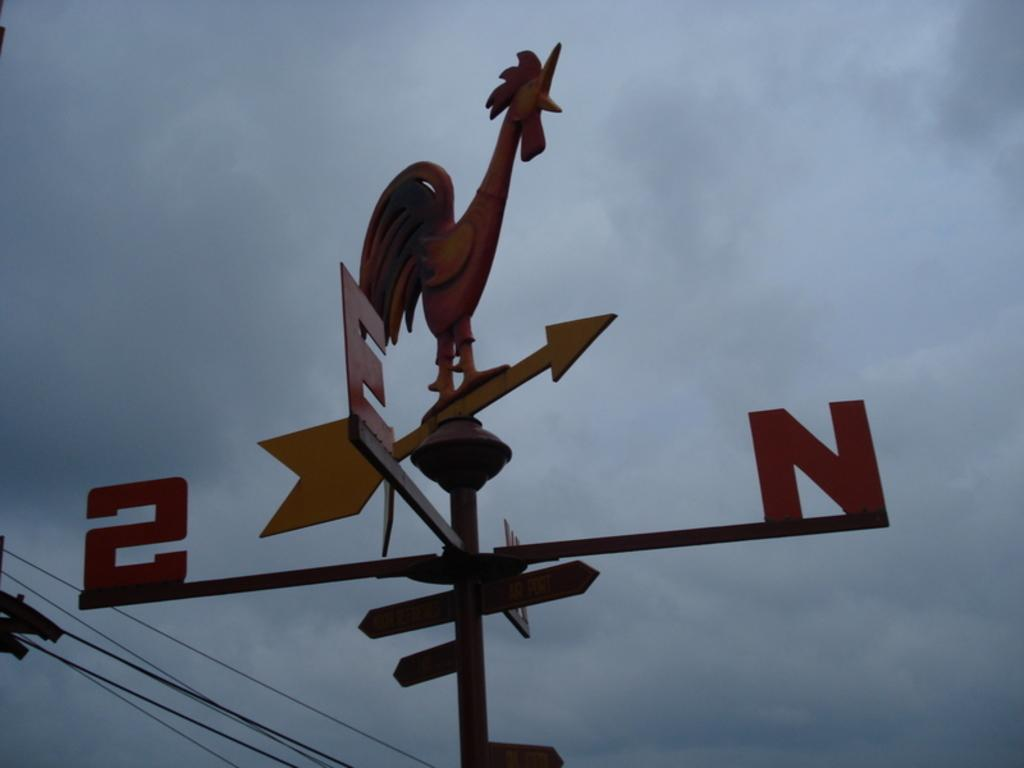What is the main object in the center of the image? There is a compass in the center of the image. What can be seen in the background of the image? There are wires and the sky visible in the background of the image. What type of woman is ringing the bells in the image? There are no women or bells present in the image; it only features a compass and wires in the background. 